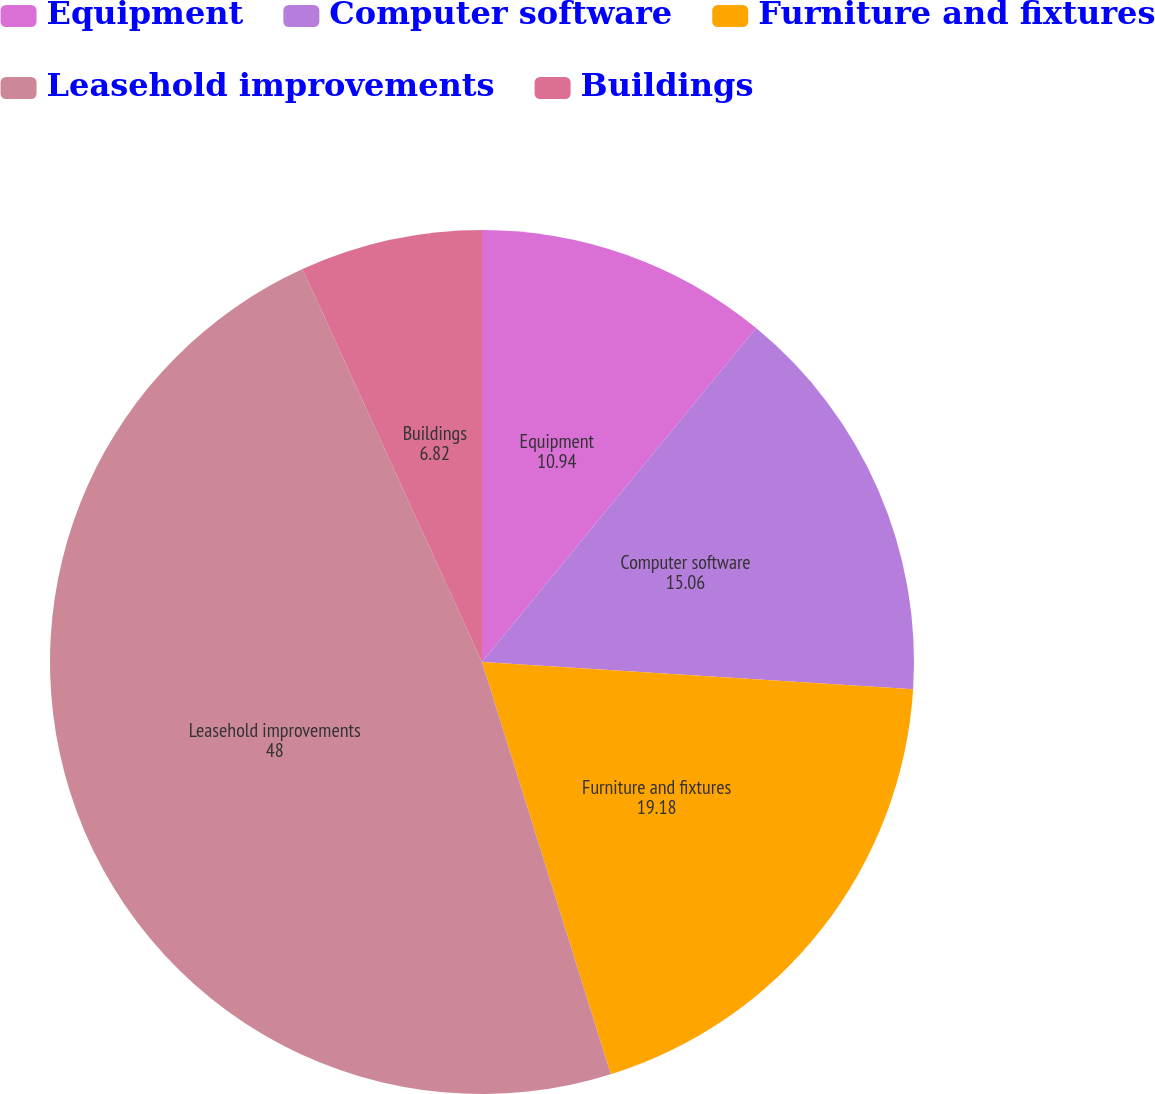Convert chart. <chart><loc_0><loc_0><loc_500><loc_500><pie_chart><fcel>Equipment<fcel>Computer software<fcel>Furniture and fixtures<fcel>Leasehold improvements<fcel>Buildings<nl><fcel>10.94%<fcel>15.06%<fcel>19.18%<fcel>48.0%<fcel>6.82%<nl></chart> 